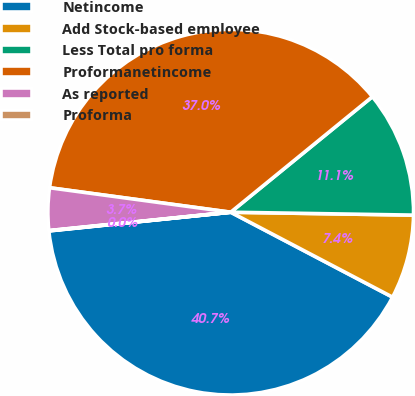Convert chart to OTSL. <chart><loc_0><loc_0><loc_500><loc_500><pie_chart><fcel>Netincome<fcel>Add Stock-based employee<fcel>Less Total pro forma<fcel>Proformanetincome<fcel>As reported<fcel>Proforma<nl><fcel>40.68%<fcel>7.44%<fcel>11.14%<fcel>36.98%<fcel>3.74%<fcel>0.03%<nl></chart> 